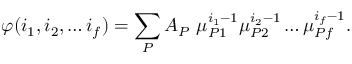<formula> <loc_0><loc_0><loc_500><loc_500>\varphi ( i _ { 1 } , i _ { 2 } , \dots i _ { f } ) = \sum _ { P } A _ { P } \ \mu _ { P 1 } ^ { i _ { 1 } - 1 } \mu _ { P 2 } ^ { i _ { 2 } - 1 } \dots \mu _ { P f } ^ { i _ { f } - 1 } .</formula> 